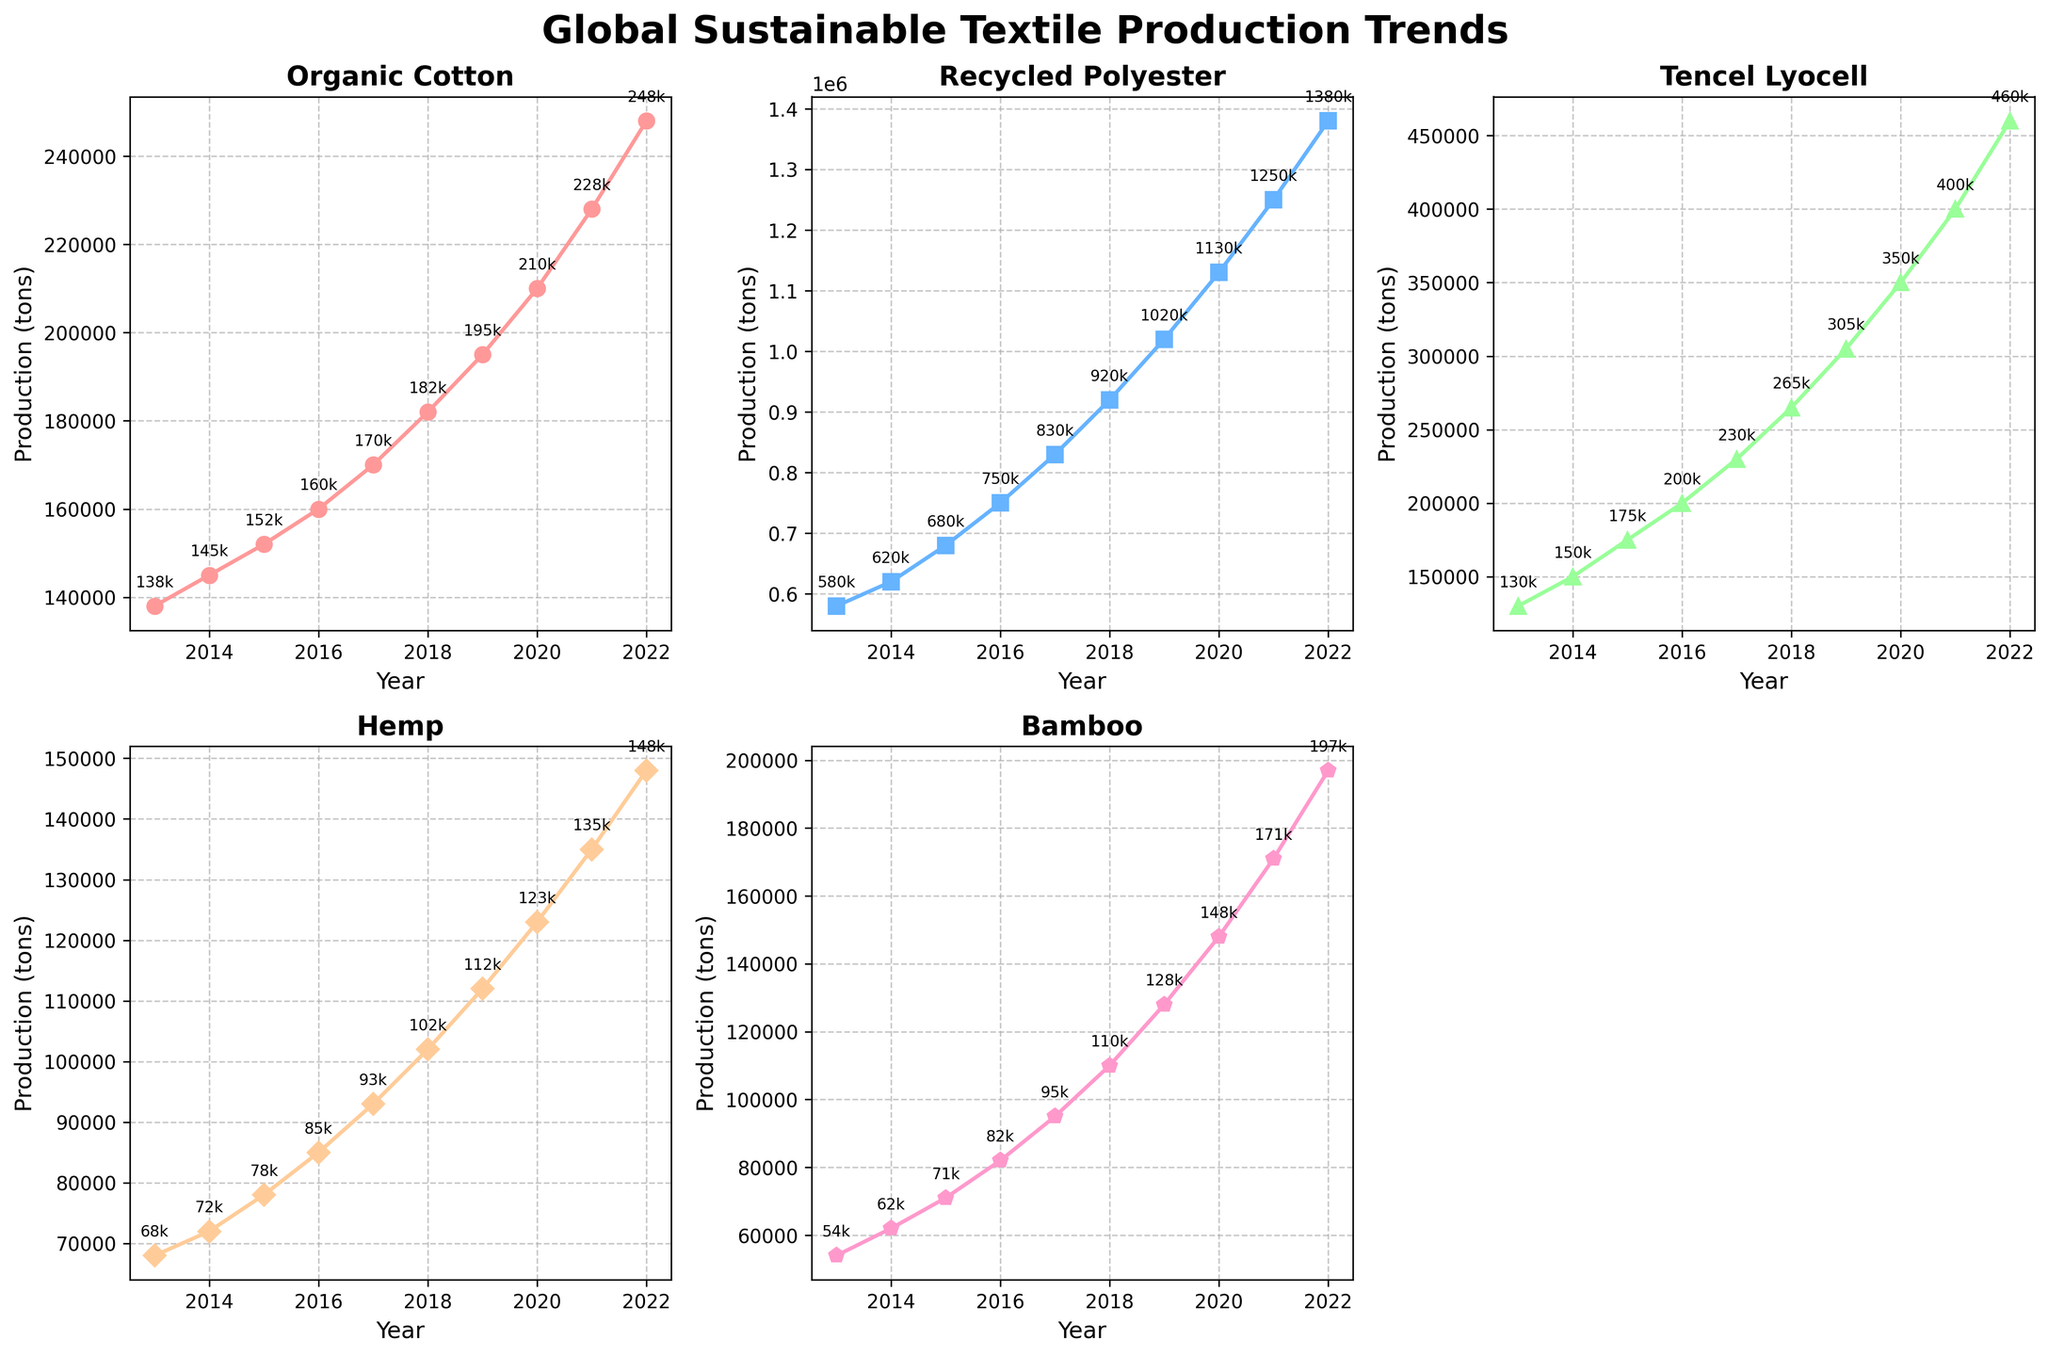What material showed the largest percentage increase in production from 2013 to 2022? To determine this, we calculate the percentage increase for each material: Organic Cotton: ((248000 - 138000) / 138000) * 100 = 79.71%, Recycled Polyester: ((1380000 - 580000) / 580000) * 100 = 137.93%, Tencel Lyocell: ((460000 - 130000) / 130000) * 100 = 253.85%, Hemp: ((148000 - 68000) / 68000) * 100 = 117.65%, Bamboo: ((197000 - 54000) / 54000) * 100 = 264.81%. Bamboo shows the largest percentage increase.
Answer: Bamboo How did the production of organic cotton compare to recycled polyester in 2022? By checking the plot, in 2022, the production of Organic Cotton is 248,000 tons, while Recycled Polyester is 1,380,000 tons. Recycled Polyester production greatly exceeds Organic Cotton.
Answer: Recycled Polyester is greater Which material had the lowest production in 2013, and what was its value? From the figure, in 2013, Bamboo had the lowest production value of 54,000 tons.
Answer: Bamboo, 54,000 tons What is the average production of Tencel Lyocell from 2013 to 2022? To calculate the average: (130000 + 150000 + 175000 + 200000 + 230000 + 265000 + 305000 + 350000 + 400000 + 460000) / 10 = 2665000 / 10 = 266,500 tons.
Answer: 266,500 tons By how much did the production of hemp increase from 2013 to 2022? Hemp production increased from 68,000 tons in 2013 to 148,000 tons in 2022. The increase is 148,000 - 68,000 = 80,000 tons.
Answer: 80,000 tons Which material had the most significant year-over-year growth starting from 2019? Observing the slopes of the plots from 2019 to 2022, Recycled Polyester shows the steepest increasing trend year-over-year.
Answer: Recycled Polyester How many materials show more than double their 2013 production in 2022? Calculating individually: Organic Cotton: (248000 / 138000) = 1.80, Recycled Polyester: (1380000 / 580000) = 2.38, Tencel Lyocell: (460000 / 130000) = 3.54, Hemp: (148000 / 68000) = 2.18, Bamboo: (197000 / 54000) = 3.65. All except Organic Cotton are greater than 2 times.
Answer: Four materials What was the production of Tencel Lyocell in 2017, and how does it compare to Hemp in the same year? According to the figure, in 2017, Tencel Lyocell had a production of 230,000 tons while Hemp had 93,000 tons. Tencel Lyocell is much higher than Hemp.
Answer: Tencel Lyocell is greater What was the production of recycled polyester in 2021 shown in scientific notation? In 2021, the production of Recycled Polyester was 1,250,000 tons. This in scientific notation is 1.25 x 10^6.
Answer: 1.25 x 10^6 